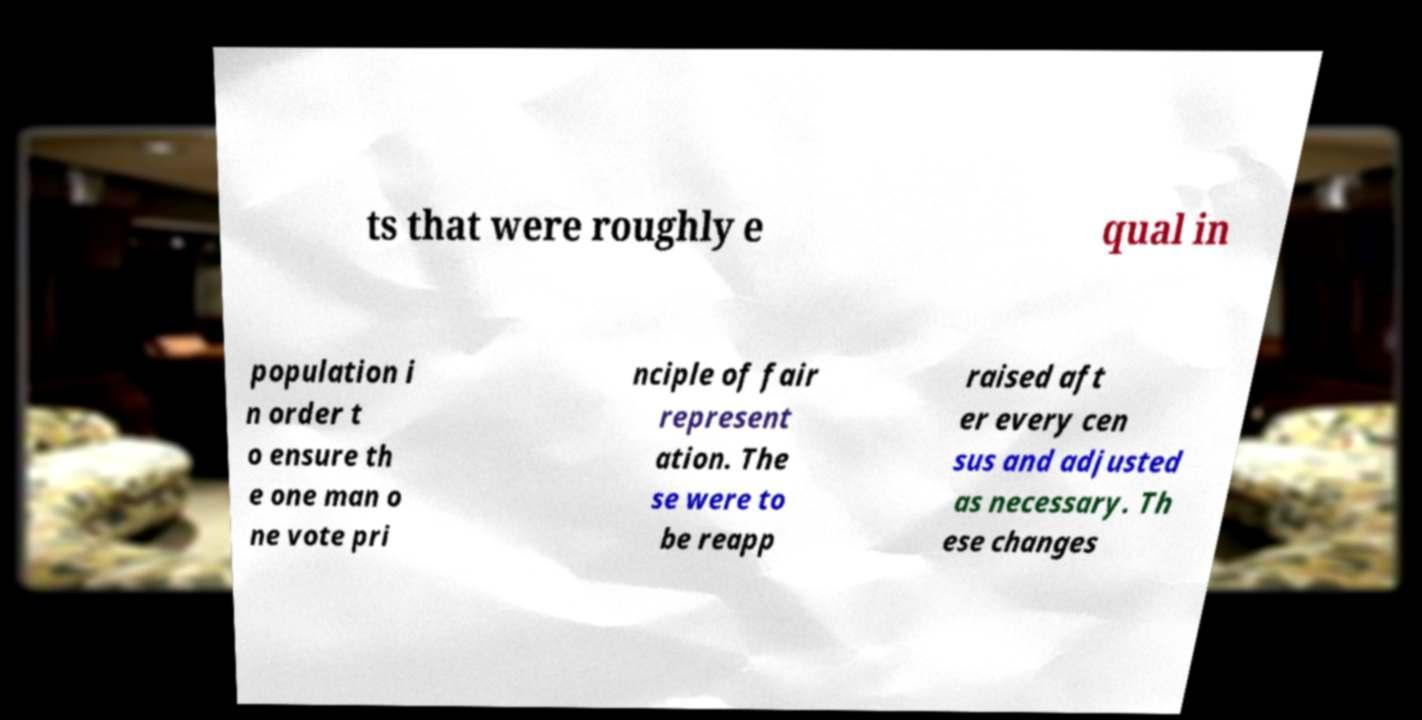Please read and relay the text visible in this image. What does it say? ts that were roughly e qual in population i n order t o ensure th e one man o ne vote pri nciple of fair represent ation. The se were to be reapp raised aft er every cen sus and adjusted as necessary. Th ese changes 